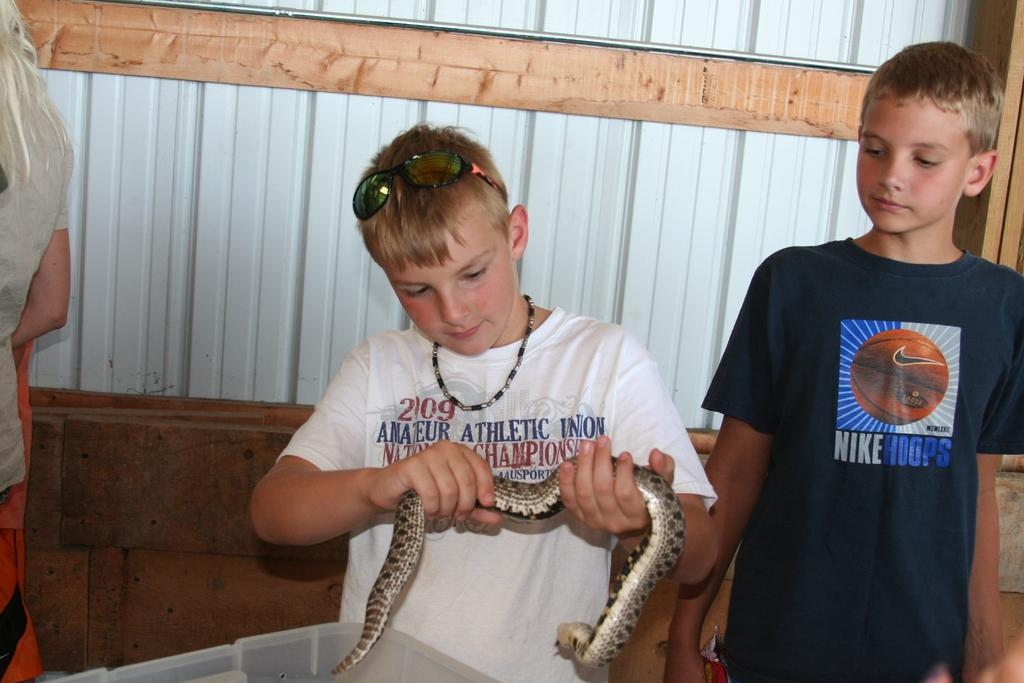How many boys are in the image? There are two boys in the image. What is the boy wearing a white t-shirt holding in his hands? The boy with the white t-shirt is holding a snake in his hands. What protective gear is the boy with the white t-shirt wearing? The boy with the white t-shirt is wearing goggles. What accessory is the boy with the white t-shirt wearing around his neck? The boy with the white t-shirt is wearing a chain around his neck. What type of kite is the boy with the white t-shirt flying in the image? There is no kite present in the image; the boy with the white t-shirt is holding a snake. How many stars can be seen in the image? There are no stars visible in the image. 